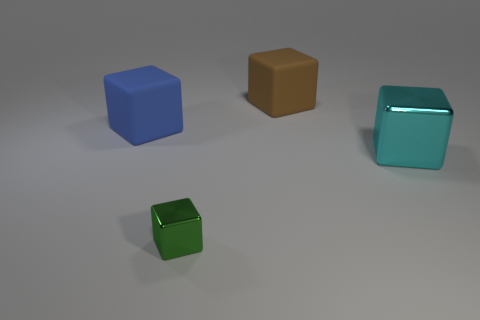Add 1 large blocks. How many objects exist? 5 Subtract all green cubes. How many cubes are left? 3 Subtract all cyan cubes. How many cubes are left? 3 Subtract 0 red spheres. How many objects are left? 4 Subtract 4 blocks. How many blocks are left? 0 Subtract all gray cubes. Subtract all cyan cylinders. How many cubes are left? 4 Subtract all blue spheres. How many cyan cubes are left? 1 Subtract all big red rubber objects. Subtract all tiny shiny blocks. How many objects are left? 3 Add 3 blue blocks. How many blue blocks are left? 4 Add 2 blue rubber blocks. How many blue rubber blocks exist? 3 